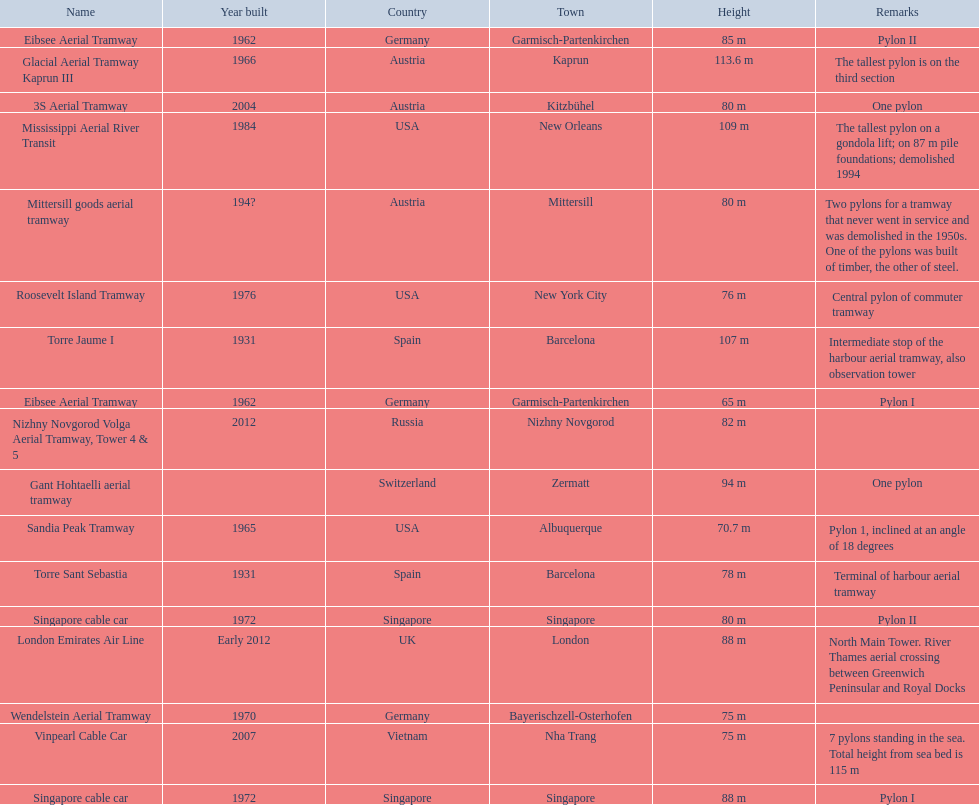Which lift has the second highest height? Mississippi Aerial River Transit. What is the value of the height? 109 m. 